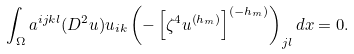Convert formula to latex. <formula><loc_0><loc_0><loc_500><loc_500>\int _ { \Omega } a ^ { i j k l } ( D ^ { 2 } u ) u _ { i k } \left ( - \left [ \zeta ^ { 4 } u ^ { \left ( h _ { m } \right ) } \right ] ^ { \left ( - h _ { m } \right ) } \right ) _ { j l } d x = 0 .</formula> 